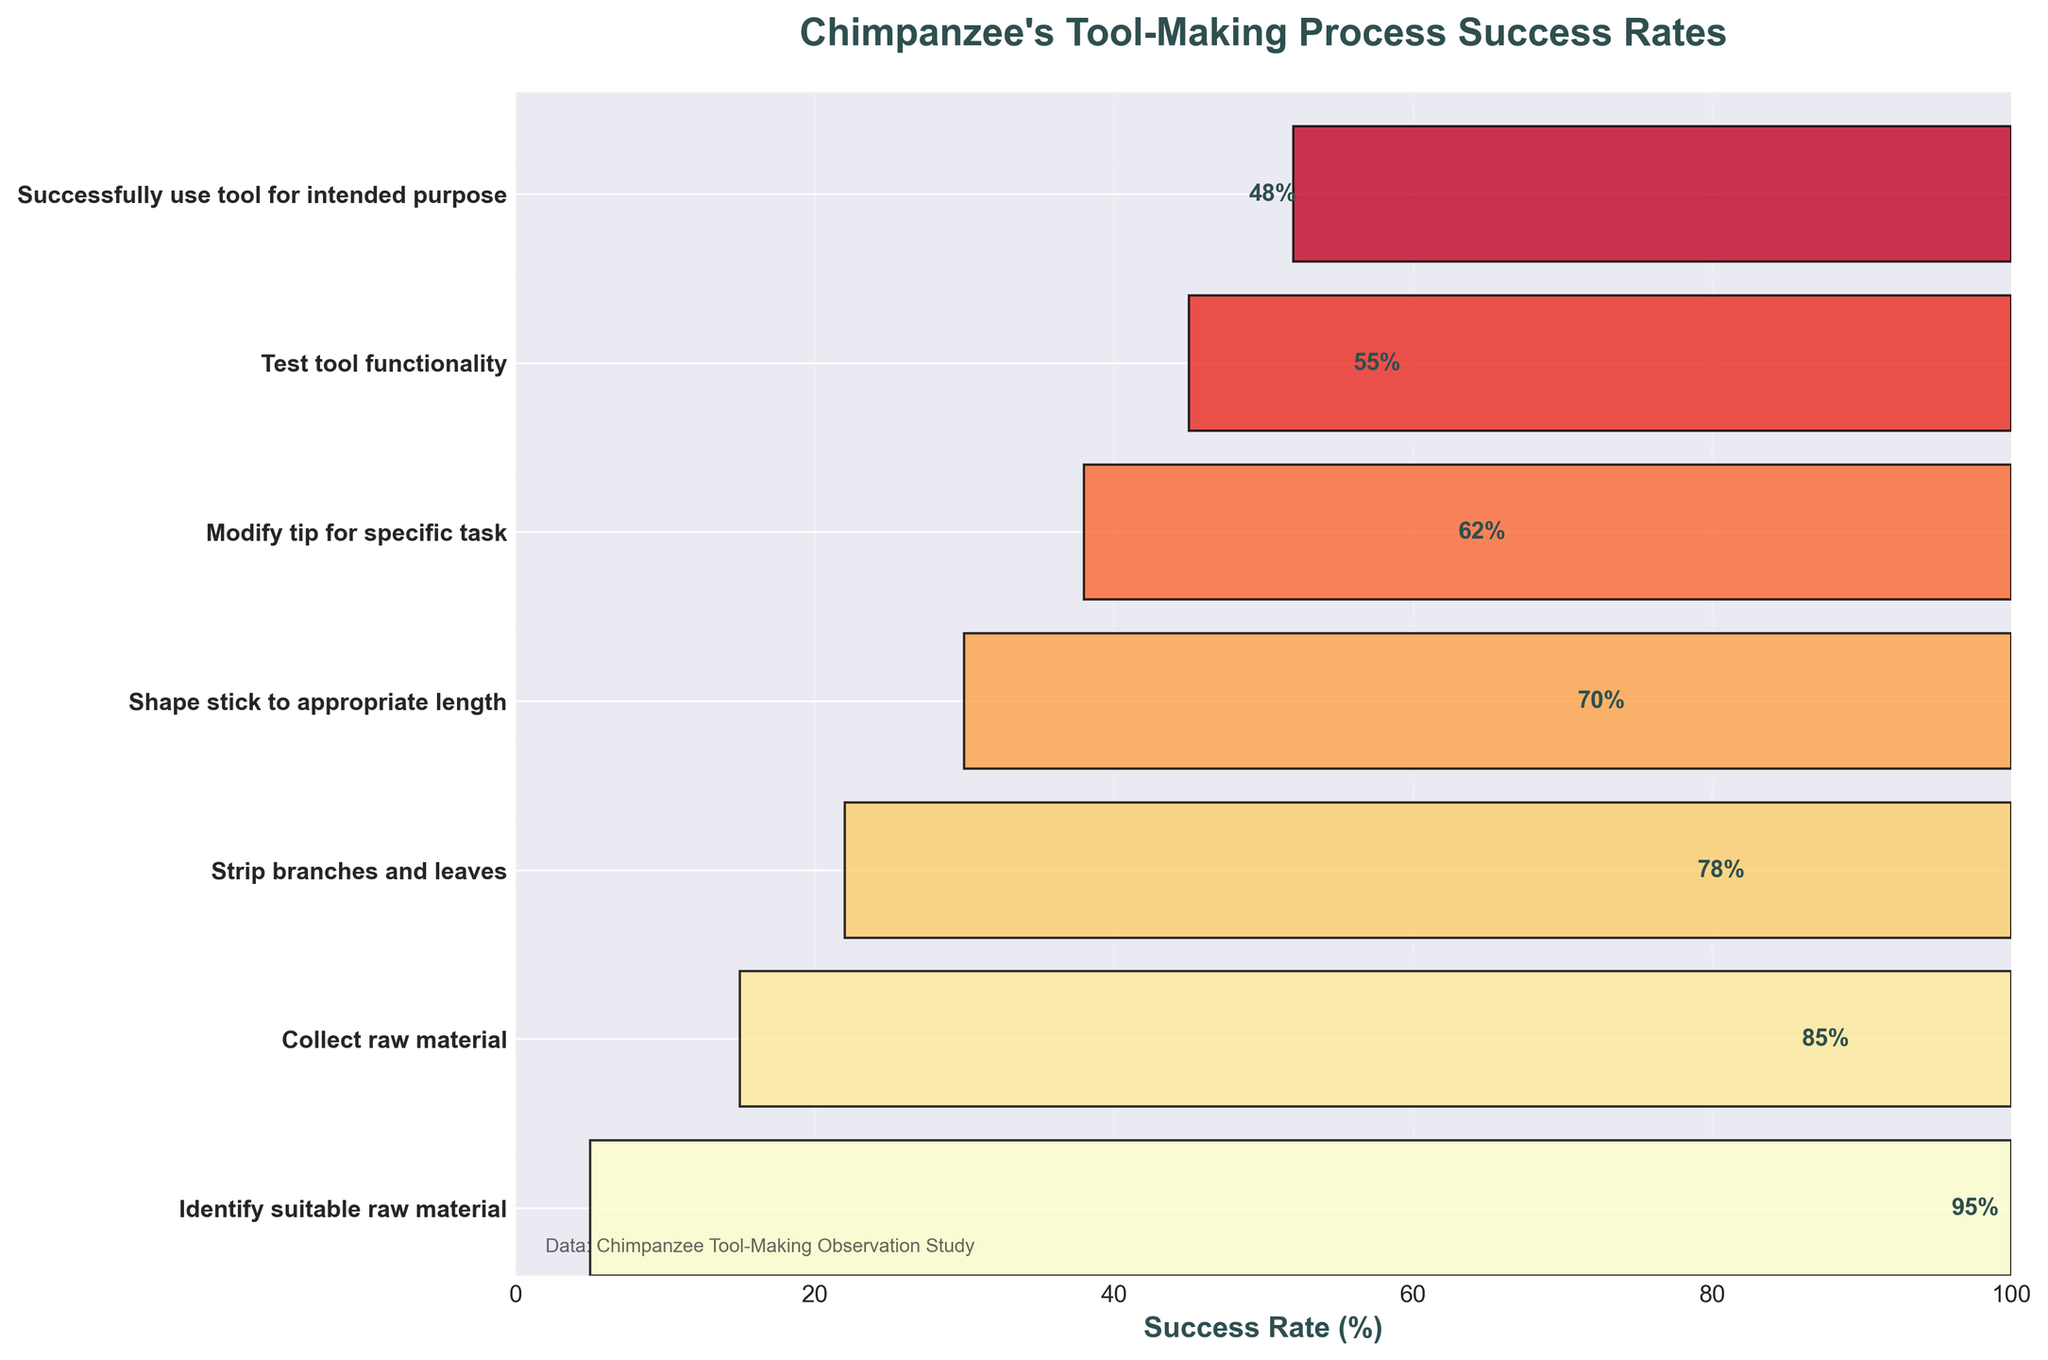What is the title of the figure? The title of the figure is usually located at the top and it provides a brief description of what the chart represents. In this case, the title mentions the process and success rates.
Answer: Chimpanzee's Tool-Making Process Success Rates What is the success rate at the first stage? The first stage is "Identify suitable raw material," and the success rate is labeled next to the corresponding section on the funnel chart.
Answer: 95% How many stages are there in the chimpanzee's tool-making process? Count the number of individual sections on the funnel chart - each section represents a stage.
Answer: 7 What is the difference in success rate between "Shape stick to appropriate length" and "Test tool functionality"? Find the success rates for both "Shape stick to appropriate length" (70%) and "Test tool functionality" (55%), then subtract the latter from the former.
Answer: 15% Which stage has the lowest success rate? Look at the success rates for each stage and identify the one with the smallest percentage. The final stage, "Successfully use tool for intended purpose", has the lowest success rate.
Answer: Successfully use tool for intended purpose How does the success rate change from the first to the last stage? Compare the success rate of the first stage (95%) with the last stage (48%). Calculate the difference.
Answer: Decreased by 47% Is the success rate higher for "Collect raw material" or "Modify tip for specific task"? Compare the success rate values for both stages: "Collect raw material" (85%) and "Modify tip for specific task" (62%).
Answer: Collect raw material What is the average success rate across all stages? Add up the success rates for all stages (95 + 85 + 78 + 70 + 62 + 55 + 48) and divide by the number of stages (7).
Answer: 70.43% Which stages have a success rate above 60%? Identify the stages with listed success rates greater than 60%. These stages are: "Identify suitable raw material" (95%), "Collect raw material" (85%), "Strip branches and leaves" (78%), "Shape stick to appropriate length" (70%), and "Modify tip for specific task" (62%).
Answer: Identify suitable raw material, Collect raw material, Strip branches and leaves, Shape stick to appropriate length, Modify tip for specific task At which stage is there the biggest drop in success rate, and what is the magnitude of this drop? Compare the difference in success rates between consecutive stages. The largest drop is between "Modify tip for specific task" (62%) and "Test tool functionality" (55%), which is 7%.
Answer: Between "Modify tip for specific task" and "Test tool functionality", 7% 